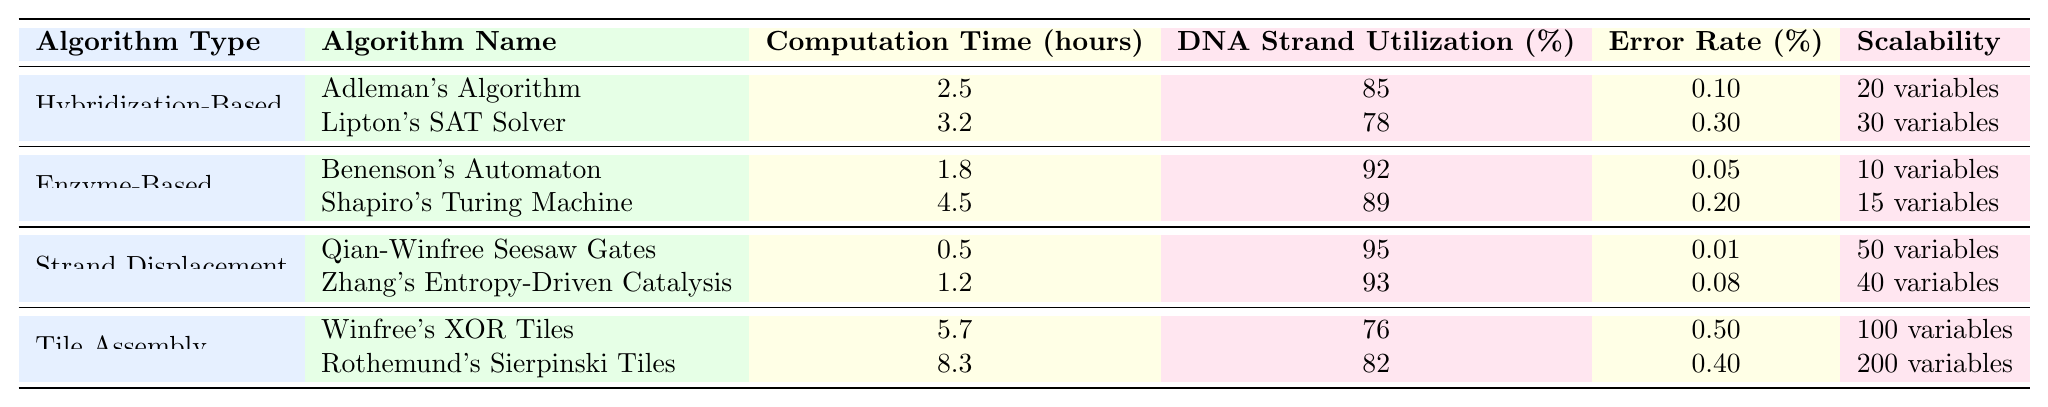What is the computation time for Adleman's Algorithm? The table shows that Adleman's Algorithm has a computation time of 2.5 hours specifically listed under its metrics.
Answer: 2.5 hours Which algorithm has the highest DNA Strand Utilization percentage? Comparing the DNA Strand Utilization percentages listed, Qian-Winfree Seesaw Gates has the highest at 95%.
Answer: 95% Is the error rate for Benenson's Automaton lower than that of Shapiro's Turing Machine? The table shows Benenson's Automaton has an error rate of 0.05%, while Shapiro's Turing Machine has an error rate of 0.20%. Since 0.05% is less than 0.20%, the statement is true.
Answer: Yes What is the average computation time for Enzyme-Based algorithms? The computation times for the Enzyme-Based algorithms are 1.8 hours for Benenson's Automaton and 4.5 hours for Shapiro's Turing Machine. To find the average, add the times (1.8 + 4.5 = 6.3 hours) and divide by the number of algorithms (6.3 / 2 = 3.15 hours).
Answer: 3.15 hours Which algorithm type has the best error rate on average? To find the average error rate for each algorithm type, we calculate the mean of the error rates listed, which are: Hybridization-Based (0.20%), Enzyme-Based (0.125%), Strand Displacement (0.045%), and Tile Assembly (0.45%). The average rates are 0.20%, 0.125%, 0.045%, and 0.45% respectively. The lowest of these is 0.045% for Strand Displacement.
Answer: Strand Displacement How many more variables can the best scalable algorithm handle compared to the least scalable algorithm? The most scalable algorithm, Rothemund's Sierpinski Tiles, can handle 200 variables while the least scalable, Benenson's Automaton, can handle only 10 variables. Therefore, the difference is 200 - 10 = 190 variables.
Answer: 190 variables Is there a correlation between computation time and DNA Strand Utilization across the algorithms? Upon examining the data closely, it appears that not all algorithms with lower computation times have higher DNA Strand Utilization; for example, Qian-Winfree Seesaw Gates has a low computation time and high utilization, while Winfree's XOR Tiles has high computation time but low utilization. Therefore, we cannot conclude a definitive correlation from this data.
Answer: No correlation can be definitively stated Which algorithm has the lowest error rate, and what is it? The table indicates that Qian-Winfree Seesaw Gates, with an error rate of 0.01%, has the lowest error rate compared to other algorithms.
Answer: Qian-Winfree Seesaw Gates, 0.01% 